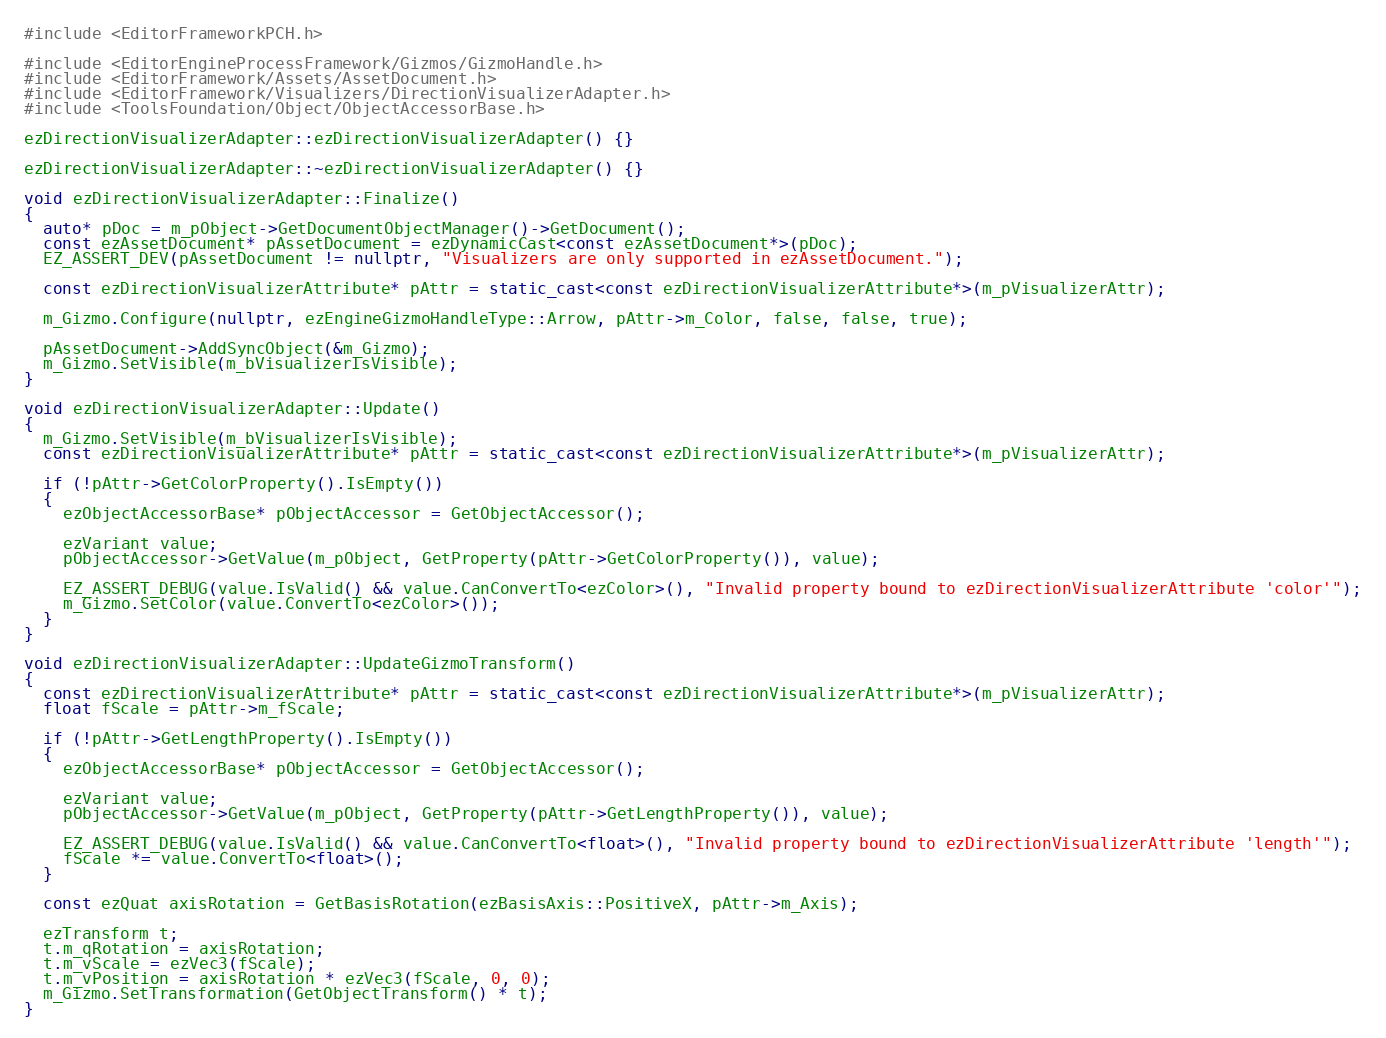Convert code to text. <code><loc_0><loc_0><loc_500><loc_500><_C++_>#include <EditorFrameworkPCH.h>

#include <EditorEngineProcessFramework/Gizmos/GizmoHandle.h>
#include <EditorFramework/Assets/AssetDocument.h>
#include <EditorFramework/Visualizers/DirectionVisualizerAdapter.h>
#include <ToolsFoundation/Object/ObjectAccessorBase.h>

ezDirectionVisualizerAdapter::ezDirectionVisualizerAdapter() {}

ezDirectionVisualizerAdapter::~ezDirectionVisualizerAdapter() {}

void ezDirectionVisualizerAdapter::Finalize()
{
  auto* pDoc = m_pObject->GetDocumentObjectManager()->GetDocument();
  const ezAssetDocument* pAssetDocument = ezDynamicCast<const ezAssetDocument*>(pDoc);
  EZ_ASSERT_DEV(pAssetDocument != nullptr, "Visualizers are only supported in ezAssetDocument.");

  const ezDirectionVisualizerAttribute* pAttr = static_cast<const ezDirectionVisualizerAttribute*>(m_pVisualizerAttr);

  m_Gizmo.Configure(nullptr, ezEngineGizmoHandleType::Arrow, pAttr->m_Color, false, false, true);

  pAssetDocument->AddSyncObject(&m_Gizmo);
  m_Gizmo.SetVisible(m_bVisualizerIsVisible);
}

void ezDirectionVisualizerAdapter::Update()
{
  m_Gizmo.SetVisible(m_bVisualizerIsVisible);
  const ezDirectionVisualizerAttribute* pAttr = static_cast<const ezDirectionVisualizerAttribute*>(m_pVisualizerAttr);

  if (!pAttr->GetColorProperty().IsEmpty())
  {
    ezObjectAccessorBase* pObjectAccessor = GetObjectAccessor();

    ezVariant value;
    pObjectAccessor->GetValue(m_pObject, GetProperty(pAttr->GetColorProperty()), value);

    EZ_ASSERT_DEBUG(value.IsValid() && value.CanConvertTo<ezColor>(), "Invalid property bound to ezDirectionVisualizerAttribute 'color'");
    m_Gizmo.SetColor(value.ConvertTo<ezColor>());
  }
}

void ezDirectionVisualizerAdapter::UpdateGizmoTransform()
{
  const ezDirectionVisualizerAttribute* pAttr = static_cast<const ezDirectionVisualizerAttribute*>(m_pVisualizerAttr);
  float fScale = pAttr->m_fScale;

  if (!pAttr->GetLengthProperty().IsEmpty())
  {
    ezObjectAccessorBase* pObjectAccessor = GetObjectAccessor();

    ezVariant value;
    pObjectAccessor->GetValue(m_pObject, GetProperty(pAttr->GetLengthProperty()), value);

    EZ_ASSERT_DEBUG(value.IsValid() && value.CanConvertTo<float>(), "Invalid property bound to ezDirectionVisualizerAttribute 'length'");
    fScale *= value.ConvertTo<float>();
  }

  const ezQuat axisRotation = GetBasisRotation(ezBasisAxis::PositiveX, pAttr->m_Axis);

  ezTransform t;
  t.m_qRotation = axisRotation;
  t.m_vScale = ezVec3(fScale);
  t.m_vPosition = axisRotation * ezVec3(fScale, 0, 0);
  m_Gizmo.SetTransformation(GetObjectTransform() * t);
}
</code> 